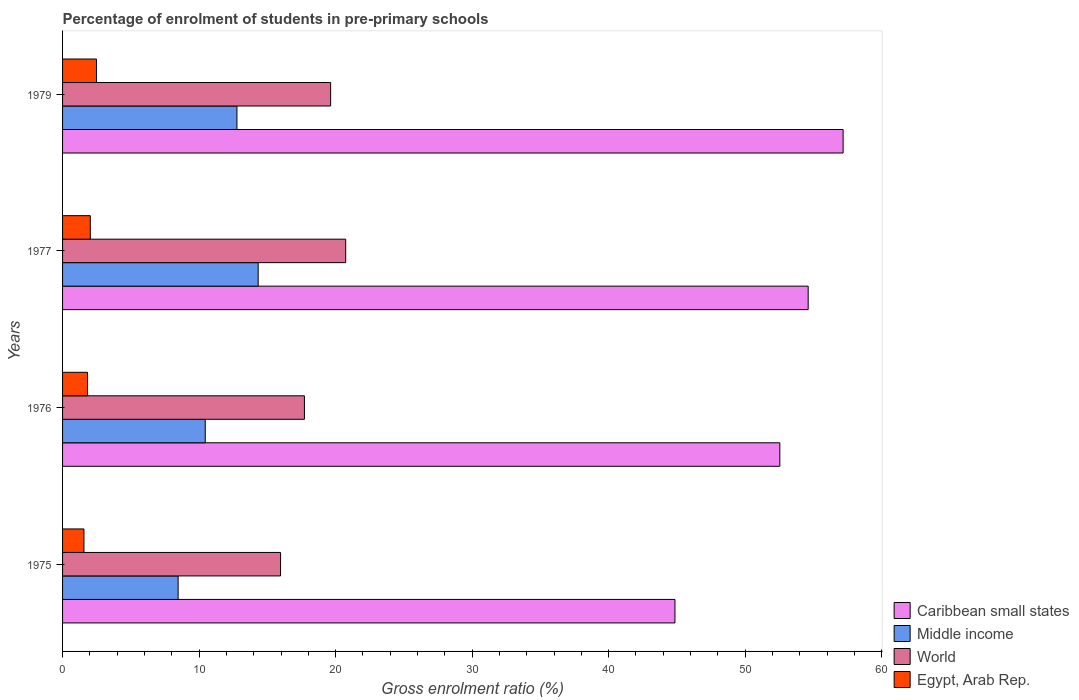How many bars are there on the 3rd tick from the bottom?
Make the answer very short. 4. What is the label of the 1st group of bars from the top?
Keep it short and to the point. 1979. What is the percentage of students enrolled in pre-primary schools in Middle income in 1975?
Make the answer very short. 8.47. Across all years, what is the maximum percentage of students enrolled in pre-primary schools in Caribbean small states?
Your answer should be compact. 57.17. Across all years, what is the minimum percentage of students enrolled in pre-primary schools in World?
Keep it short and to the point. 15.97. In which year was the percentage of students enrolled in pre-primary schools in World maximum?
Ensure brevity in your answer.  1977. In which year was the percentage of students enrolled in pre-primary schools in Egypt, Arab Rep. minimum?
Give a very brief answer. 1975. What is the total percentage of students enrolled in pre-primary schools in Caribbean small states in the graph?
Make the answer very short. 209.19. What is the difference between the percentage of students enrolled in pre-primary schools in Middle income in 1975 and that in 1976?
Your answer should be compact. -1.99. What is the difference between the percentage of students enrolled in pre-primary schools in Middle income in 1977 and the percentage of students enrolled in pre-primary schools in World in 1975?
Provide a succinct answer. -1.64. What is the average percentage of students enrolled in pre-primary schools in Middle income per year?
Offer a very short reply. 11.5. In the year 1975, what is the difference between the percentage of students enrolled in pre-primary schools in Egypt, Arab Rep. and percentage of students enrolled in pre-primary schools in Caribbean small states?
Ensure brevity in your answer.  -43.29. What is the ratio of the percentage of students enrolled in pre-primary schools in Middle income in 1975 to that in 1979?
Provide a short and direct response. 0.66. Is the percentage of students enrolled in pre-primary schools in Caribbean small states in 1976 less than that in 1977?
Provide a succinct answer. Yes. Is the difference between the percentage of students enrolled in pre-primary schools in Egypt, Arab Rep. in 1976 and 1979 greater than the difference between the percentage of students enrolled in pre-primary schools in Caribbean small states in 1976 and 1979?
Provide a short and direct response. Yes. What is the difference between the highest and the second highest percentage of students enrolled in pre-primary schools in Middle income?
Make the answer very short. 1.56. What is the difference between the highest and the lowest percentage of students enrolled in pre-primary schools in World?
Offer a very short reply. 4.77. Is the sum of the percentage of students enrolled in pre-primary schools in Egypt, Arab Rep. in 1975 and 1977 greater than the maximum percentage of students enrolled in pre-primary schools in World across all years?
Your answer should be very brief. No. What does the 1st bar from the top in 1979 represents?
Ensure brevity in your answer.  Egypt, Arab Rep. What does the 4th bar from the bottom in 1977 represents?
Ensure brevity in your answer.  Egypt, Arab Rep. How many years are there in the graph?
Keep it short and to the point. 4. Are the values on the major ticks of X-axis written in scientific E-notation?
Provide a short and direct response. No. Does the graph contain any zero values?
Keep it short and to the point. No. Does the graph contain grids?
Offer a very short reply. No. How are the legend labels stacked?
Keep it short and to the point. Vertical. What is the title of the graph?
Provide a succinct answer. Percentage of enrolment of students in pre-primary schools. What is the label or title of the Y-axis?
Your response must be concise. Years. What is the Gross enrolment ratio (%) of Caribbean small states in 1975?
Provide a short and direct response. 44.86. What is the Gross enrolment ratio (%) in Middle income in 1975?
Provide a short and direct response. 8.47. What is the Gross enrolment ratio (%) in World in 1975?
Keep it short and to the point. 15.97. What is the Gross enrolment ratio (%) in Egypt, Arab Rep. in 1975?
Offer a terse response. 1.57. What is the Gross enrolment ratio (%) of Caribbean small states in 1976?
Make the answer very short. 52.54. What is the Gross enrolment ratio (%) in Middle income in 1976?
Ensure brevity in your answer.  10.45. What is the Gross enrolment ratio (%) in World in 1976?
Offer a terse response. 17.72. What is the Gross enrolment ratio (%) in Egypt, Arab Rep. in 1976?
Offer a terse response. 1.83. What is the Gross enrolment ratio (%) in Caribbean small states in 1977?
Offer a very short reply. 54.61. What is the Gross enrolment ratio (%) in Middle income in 1977?
Provide a succinct answer. 14.33. What is the Gross enrolment ratio (%) of World in 1977?
Ensure brevity in your answer.  20.74. What is the Gross enrolment ratio (%) in Egypt, Arab Rep. in 1977?
Ensure brevity in your answer.  2.03. What is the Gross enrolment ratio (%) in Caribbean small states in 1979?
Keep it short and to the point. 57.17. What is the Gross enrolment ratio (%) of Middle income in 1979?
Your answer should be compact. 12.77. What is the Gross enrolment ratio (%) in World in 1979?
Provide a short and direct response. 19.64. What is the Gross enrolment ratio (%) of Egypt, Arab Rep. in 1979?
Your answer should be very brief. 2.48. Across all years, what is the maximum Gross enrolment ratio (%) in Caribbean small states?
Keep it short and to the point. 57.17. Across all years, what is the maximum Gross enrolment ratio (%) in Middle income?
Offer a terse response. 14.33. Across all years, what is the maximum Gross enrolment ratio (%) in World?
Your answer should be compact. 20.74. Across all years, what is the maximum Gross enrolment ratio (%) in Egypt, Arab Rep.?
Your response must be concise. 2.48. Across all years, what is the minimum Gross enrolment ratio (%) of Caribbean small states?
Make the answer very short. 44.86. Across all years, what is the minimum Gross enrolment ratio (%) in Middle income?
Your answer should be very brief. 8.47. Across all years, what is the minimum Gross enrolment ratio (%) in World?
Provide a succinct answer. 15.97. Across all years, what is the minimum Gross enrolment ratio (%) in Egypt, Arab Rep.?
Your answer should be very brief. 1.57. What is the total Gross enrolment ratio (%) of Caribbean small states in the graph?
Offer a very short reply. 209.19. What is the total Gross enrolment ratio (%) of Middle income in the graph?
Provide a short and direct response. 46.02. What is the total Gross enrolment ratio (%) in World in the graph?
Your response must be concise. 74.06. What is the total Gross enrolment ratio (%) of Egypt, Arab Rep. in the graph?
Your answer should be compact. 7.91. What is the difference between the Gross enrolment ratio (%) of Caribbean small states in 1975 and that in 1976?
Make the answer very short. -7.68. What is the difference between the Gross enrolment ratio (%) of Middle income in 1975 and that in 1976?
Make the answer very short. -1.99. What is the difference between the Gross enrolment ratio (%) in World in 1975 and that in 1976?
Your response must be concise. -1.75. What is the difference between the Gross enrolment ratio (%) of Egypt, Arab Rep. in 1975 and that in 1976?
Provide a succinct answer. -0.26. What is the difference between the Gross enrolment ratio (%) of Caribbean small states in 1975 and that in 1977?
Offer a very short reply. -9.76. What is the difference between the Gross enrolment ratio (%) of Middle income in 1975 and that in 1977?
Your answer should be very brief. -5.86. What is the difference between the Gross enrolment ratio (%) of World in 1975 and that in 1977?
Provide a short and direct response. -4.77. What is the difference between the Gross enrolment ratio (%) in Egypt, Arab Rep. in 1975 and that in 1977?
Provide a short and direct response. -0.47. What is the difference between the Gross enrolment ratio (%) of Caribbean small states in 1975 and that in 1979?
Give a very brief answer. -12.32. What is the difference between the Gross enrolment ratio (%) in Middle income in 1975 and that in 1979?
Provide a short and direct response. -4.31. What is the difference between the Gross enrolment ratio (%) of World in 1975 and that in 1979?
Your answer should be compact. -3.67. What is the difference between the Gross enrolment ratio (%) of Egypt, Arab Rep. in 1975 and that in 1979?
Your response must be concise. -0.92. What is the difference between the Gross enrolment ratio (%) in Caribbean small states in 1976 and that in 1977?
Offer a very short reply. -2.07. What is the difference between the Gross enrolment ratio (%) in Middle income in 1976 and that in 1977?
Make the answer very short. -3.88. What is the difference between the Gross enrolment ratio (%) in World in 1976 and that in 1977?
Your answer should be very brief. -3.02. What is the difference between the Gross enrolment ratio (%) in Egypt, Arab Rep. in 1976 and that in 1977?
Offer a terse response. -0.2. What is the difference between the Gross enrolment ratio (%) in Caribbean small states in 1976 and that in 1979?
Your answer should be very brief. -4.63. What is the difference between the Gross enrolment ratio (%) in Middle income in 1976 and that in 1979?
Offer a very short reply. -2.32. What is the difference between the Gross enrolment ratio (%) in World in 1976 and that in 1979?
Your answer should be compact. -1.92. What is the difference between the Gross enrolment ratio (%) of Egypt, Arab Rep. in 1976 and that in 1979?
Make the answer very short. -0.66. What is the difference between the Gross enrolment ratio (%) in Caribbean small states in 1977 and that in 1979?
Make the answer very short. -2.56. What is the difference between the Gross enrolment ratio (%) in Middle income in 1977 and that in 1979?
Keep it short and to the point. 1.56. What is the difference between the Gross enrolment ratio (%) in World in 1977 and that in 1979?
Provide a short and direct response. 1.1. What is the difference between the Gross enrolment ratio (%) in Egypt, Arab Rep. in 1977 and that in 1979?
Keep it short and to the point. -0.45. What is the difference between the Gross enrolment ratio (%) in Caribbean small states in 1975 and the Gross enrolment ratio (%) in Middle income in 1976?
Your answer should be compact. 34.41. What is the difference between the Gross enrolment ratio (%) in Caribbean small states in 1975 and the Gross enrolment ratio (%) in World in 1976?
Your answer should be very brief. 27.14. What is the difference between the Gross enrolment ratio (%) in Caribbean small states in 1975 and the Gross enrolment ratio (%) in Egypt, Arab Rep. in 1976?
Make the answer very short. 43.03. What is the difference between the Gross enrolment ratio (%) of Middle income in 1975 and the Gross enrolment ratio (%) of World in 1976?
Ensure brevity in your answer.  -9.25. What is the difference between the Gross enrolment ratio (%) in Middle income in 1975 and the Gross enrolment ratio (%) in Egypt, Arab Rep. in 1976?
Your answer should be compact. 6.64. What is the difference between the Gross enrolment ratio (%) in World in 1975 and the Gross enrolment ratio (%) in Egypt, Arab Rep. in 1976?
Provide a succinct answer. 14.14. What is the difference between the Gross enrolment ratio (%) in Caribbean small states in 1975 and the Gross enrolment ratio (%) in Middle income in 1977?
Offer a very short reply. 30.53. What is the difference between the Gross enrolment ratio (%) of Caribbean small states in 1975 and the Gross enrolment ratio (%) of World in 1977?
Provide a succinct answer. 24.12. What is the difference between the Gross enrolment ratio (%) of Caribbean small states in 1975 and the Gross enrolment ratio (%) of Egypt, Arab Rep. in 1977?
Offer a terse response. 42.82. What is the difference between the Gross enrolment ratio (%) in Middle income in 1975 and the Gross enrolment ratio (%) in World in 1977?
Keep it short and to the point. -12.27. What is the difference between the Gross enrolment ratio (%) in Middle income in 1975 and the Gross enrolment ratio (%) in Egypt, Arab Rep. in 1977?
Your answer should be compact. 6.43. What is the difference between the Gross enrolment ratio (%) in World in 1975 and the Gross enrolment ratio (%) in Egypt, Arab Rep. in 1977?
Your response must be concise. 13.94. What is the difference between the Gross enrolment ratio (%) in Caribbean small states in 1975 and the Gross enrolment ratio (%) in Middle income in 1979?
Your answer should be compact. 32.08. What is the difference between the Gross enrolment ratio (%) in Caribbean small states in 1975 and the Gross enrolment ratio (%) in World in 1979?
Your answer should be compact. 25.22. What is the difference between the Gross enrolment ratio (%) in Caribbean small states in 1975 and the Gross enrolment ratio (%) in Egypt, Arab Rep. in 1979?
Give a very brief answer. 42.37. What is the difference between the Gross enrolment ratio (%) of Middle income in 1975 and the Gross enrolment ratio (%) of World in 1979?
Keep it short and to the point. -11.17. What is the difference between the Gross enrolment ratio (%) in Middle income in 1975 and the Gross enrolment ratio (%) in Egypt, Arab Rep. in 1979?
Make the answer very short. 5.98. What is the difference between the Gross enrolment ratio (%) of World in 1975 and the Gross enrolment ratio (%) of Egypt, Arab Rep. in 1979?
Make the answer very short. 13.48. What is the difference between the Gross enrolment ratio (%) of Caribbean small states in 1976 and the Gross enrolment ratio (%) of Middle income in 1977?
Make the answer very short. 38.21. What is the difference between the Gross enrolment ratio (%) of Caribbean small states in 1976 and the Gross enrolment ratio (%) of World in 1977?
Provide a short and direct response. 31.8. What is the difference between the Gross enrolment ratio (%) in Caribbean small states in 1976 and the Gross enrolment ratio (%) in Egypt, Arab Rep. in 1977?
Your answer should be very brief. 50.51. What is the difference between the Gross enrolment ratio (%) of Middle income in 1976 and the Gross enrolment ratio (%) of World in 1977?
Provide a short and direct response. -10.29. What is the difference between the Gross enrolment ratio (%) in Middle income in 1976 and the Gross enrolment ratio (%) in Egypt, Arab Rep. in 1977?
Keep it short and to the point. 8.42. What is the difference between the Gross enrolment ratio (%) in World in 1976 and the Gross enrolment ratio (%) in Egypt, Arab Rep. in 1977?
Offer a terse response. 15.68. What is the difference between the Gross enrolment ratio (%) in Caribbean small states in 1976 and the Gross enrolment ratio (%) in Middle income in 1979?
Give a very brief answer. 39.77. What is the difference between the Gross enrolment ratio (%) in Caribbean small states in 1976 and the Gross enrolment ratio (%) in World in 1979?
Make the answer very short. 32.9. What is the difference between the Gross enrolment ratio (%) of Caribbean small states in 1976 and the Gross enrolment ratio (%) of Egypt, Arab Rep. in 1979?
Provide a short and direct response. 50.06. What is the difference between the Gross enrolment ratio (%) in Middle income in 1976 and the Gross enrolment ratio (%) in World in 1979?
Your answer should be very brief. -9.19. What is the difference between the Gross enrolment ratio (%) in Middle income in 1976 and the Gross enrolment ratio (%) in Egypt, Arab Rep. in 1979?
Keep it short and to the point. 7.97. What is the difference between the Gross enrolment ratio (%) of World in 1976 and the Gross enrolment ratio (%) of Egypt, Arab Rep. in 1979?
Give a very brief answer. 15.23. What is the difference between the Gross enrolment ratio (%) in Caribbean small states in 1977 and the Gross enrolment ratio (%) in Middle income in 1979?
Ensure brevity in your answer.  41.84. What is the difference between the Gross enrolment ratio (%) in Caribbean small states in 1977 and the Gross enrolment ratio (%) in World in 1979?
Provide a succinct answer. 34.98. What is the difference between the Gross enrolment ratio (%) in Caribbean small states in 1977 and the Gross enrolment ratio (%) in Egypt, Arab Rep. in 1979?
Provide a short and direct response. 52.13. What is the difference between the Gross enrolment ratio (%) in Middle income in 1977 and the Gross enrolment ratio (%) in World in 1979?
Your response must be concise. -5.31. What is the difference between the Gross enrolment ratio (%) in Middle income in 1977 and the Gross enrolment ratio (%) in Egypt, Arab Rep. in 1979?
Your answer should be very brief. 11.84. What is the difference between the Gross enrolment ratio (%) of World in 1977 and the Gross enrolment ratio (%) of Egypt, Arab Rep. in 1979?
Ensure brevity in your answer.  18.25. What is the average Gross enrolment ratio (%) of Caribbean small states per year?
Your response must be concise. 52.3. What is the average Gross enrolment ratio (%) of Middle income per year?
Your response must be concise. 11.5. What is the average Gross enrolment ratio (%) of World per year?
Keep it short and to the point. 18.51. What is the average Gross enrolment ratio (%) in Egypt, Arab Rep. per year?
Offer a terse response. 1.98. In the year 1975, what is the difference between the Gross enrolment ratio (%) in Caribbean small states and Gross enrolment ratio (%) in Middle income?
Your answer should be compact. 36.39. In the year 1975, what is the difference between the Gross enrolment ratio (%) of Caribbean small states and Gross enrolment ratio (%) of World?
Ensure brevity in your answer.  28.89. In the year 1975, what is the difference between the Gross enrolment ratio (%) in Caribbean small states and Gross enrolment ratio (%) in Egypt, Arab Rep.?
Offer a very short reply. 43.29. In the year 1975, what is the difference between the Gross enrolment ratio (%) in Middle income and Gross enrolment ratio (%) in World?
Your response must be concise. -7.5. In the year 1975, what is the difference between the Gross enrolment ratio (%) in Middle income and Gross enrolment ratio (%) in Egypt, Arab Rep.?
Your response must be concise. 6.9. In the year 1975, what is the difference between the Gross enrolment ratio (%) of World and Gross enrolment ratio (%) of Egypt, Arab Rep.?
Ensure brevity in your answer.  14.4. In the year 1976, what is the difference between the Gross enrolment ratio (%) in Caribbean small states and Gross enrolment ratio (%) in Middle income?
Give a very brief answer. 42.09. In the year 1976, what is the difference between the Gross enrolment ratio (%) in Caribbean small states and Gross enrolment ratio (%) in World?
Provide a short and direct response. 34.82. In the year 1976, what is the difference between the Gross enrolment ratio (%) of Caribbean small states and Gross enrolment ratio (%) of Egypt, Arab Rep.?
Provide a succinct answer. 50.71. In the year 1976, what is the difference between the Gross enrolment ratio (%) in Middle income and Gross enrolment ratio (%) in World?
Your response must be concise. -7.26. In the year 1976, what is the difference between the Gross enrolment ratio (%) of Middle income and Gross enrolment ratio (%) of Egypt, Arab Rep.?
Provide a succinct answer. 8.62. In the year 1976, what is the difference between the Gross enrolment ratio (%) in World and Gross enrolment ratio (%) in Egypt, Arab Rep.?
Offer a terse response. 15.89. In the year 1977, what is the difference between the Gross enrolment ratio (%) in Caribbean small states and Gross enrolment ratio (%) in Middle income?
Keep it short and to the point. 40.29. In the year 1977, what is the difference between the Gross enrolment ratio (%) in Caribbean small states and Gross enrolment ratio (%) in World?
Keep it short and to the point. 33.88. In the year 1977, what is the difference between the Gross enrolment ratio (%) in Caribbean small states and Gross enrolment ratio (%) in Egypt, Arab Rep.?
Provide a short and direct response. 52.58. In the year 1977, what is the difference between the Gross enrolment ratio (%) in Middle income and Gross enrolment ratio (%) in World?
Your answer should be compact. -6.41. In the year 1977, what is the difference between the Gross enrolment ratio (%) in Middle income and Gross enrolment ratio (%) in Egypt, Arab Rep.?
Ensure brevity in your answer.  12.3. In the year 1977, what is the difference between the Gross enrolment ratio (%) of World and Gross enrolment ratio (%) of Egypt, Arab Rep.?
Provide a short and direct response. 18.71. In the year 1979, what is the difference between the Gross enrolment ratio (%) in Caribbean small states and Gross enrolment ratio (%) in Middle income?
Give a very brief answer. 44.4. In the year 1979, what is the difference between the Gross enrolment ratio (%) in Caribbean small states and Gross enrolment ratio (%) in World?
Give a very brief answer. 37.54. In the year 1979, what is the difference between the Gross enrolment ratio (%) in Caribbean small states and Gross enrolment ratio (%) in Egypt, Arab Rep.?
Your response must be concise. 54.69. In the year 1979, what is the difference between the Gross enrolment ratio (%) in Middle income and Gross enrolment ratio (%) in World?
Provide a succinct answer. -6.86. In the year 1979, what is the difference between the Gross enrolment ratio (%) in Middle income and Gross enrolment ratio (%) in Egypt, Arab Rep.?
Your response must be concise. 10.29. In the year 1979, what is the difference between the Gross enrolment ratio (%) of World and Gross enrolment ratio (%) of Egypt, Arab Rep.?
Give a very brief answer. 17.15. What is the ratio of the Gross enrolment ratio (%) of Caribbean small states in 1975 to that in 1976?
Your answer should be very brief. 0.85. What is the ratio of the Gross enrolment ratio (%) of Middle income in 1975 to that in 1976?
Offer a very short reply. 0.81. What is the ratio of the Gross enrolment ratio (%) in World in 1975 to that in 1976?
Keep it short and to the point. 0.9. What is the ratio of the Gross enrolment ratio (%) of Egypt, Arab Rep. in 1975 to that in 1976?
Your response must be concise. 0.86. What is the ratio of the Gross enrolment ratio (%) of Caribbean small states in 1975 to that in 1977?
Make the answer very short. 0.82. What is the ratio of the Gross enrolment ratio (%) of Middle income in 1975 to that in 1977?
Make the answer very short. 0.59. What is the ratio of the Gross enrolment ratio (%) of World in 1975 to that in 1977?
Your answer should be very brief. 0.77. What is the ratio of the Gross enrolment ratio (%) in Egypt, Arab Rep. in 1975 to that in 1977?
Give a very brief answer. 0.77. What is the ratio of the Gross enrolment ratio (%) in Caribbean small states in 1975 to that in 1979?
Provide a succinct answer. 0.78. What is the ratio of the Gross enrolment ratio (%) in Middle income in 1975 to that in 1979?
Your response must be concise. 0.66. What is the ratio of the Gross enrolment ratio (%) in World in 1975 to that in 1979?
Make the answer very short. 0.81. What is the ratio of the Gross enrolment ratio (%) in Egypt, Arab Rep. in 1975 to that in 1979?
Make the answer very short. 0.63. What is the ratio of the Gross enrolment ratio (%) in Caribbean small states in 1976 to that in 1977?
Your answer should be very brief. 0.96. What is the ratio of the Gross enrolment ratio (%) of Middle income in 1976 to that in 1977?
Offer a terse response. 0.73. What is the ratio of the Gross enrolment ratio (%) of World in 1976 to that in 1977?
Provide a succinct answer. 0.85. What is the ratio of the Gross enrolment ratio (%) of Egypt, Arab Rep. in 1976 to that in 1977?
Keep it short and to the point. 0.9. What is the ratio of the Gross enrolment ratio (%) in Caribbean small states in 1976 to that in 1979?
Make the answer very short. 0.92. What is the ratio of the Gross enrolment ratio (%) of Middle income in 1976 to that in 1979?
Your answer should be compact. 0.82. What is the ratio of the Gross enrolment ratio (%) of World in 1976 to that in 1979?
Give a very brief answer. 0.9. What is the ratio of the Gross enrolment ratio (%) in Egypt, Arab Rep. in 1976 to that in 1979?
Give a very brief answer. 0.74. What is the ratio of the Gross enrolment ratio (%) of Caribbean small states in 1977 to that in 1979?
Keep it short and to the point. 0.96. What is the ratio of the Gross enrolment ratio (%) of Middle income in 1977 to that in 1979?
Offer a terse response. 1.12. What is the ratio of the Gross enrolment ratio (%) in World in 1977 to that in 1979?
Your answer should be very brief. 1.06. What is the ratio of the Gross enrolment ratio (%) of Egypt, Arab Rep. in 1977 to that in 1979?
Give a very brief answer. 0.82. What is the difference between the highest and the second highest Gross enrolment ratio (%) in Caribbean small states?
Your answer should be very brief. 2.56. What is the difference between the highest and the second highest Gross enrolment ratio (%) of Middle income?
Your response must be concise. 1.56. What is the difference between the highest and the second highest Gross enrolment ratio (%) of World?
Your answer should be compact. 1.1. What is the difference between the highest and the second highest Gross enrolment ratio (%) of Egypt, Arab Rep.?
Offer a terse response. 0.45. What is the difference between the highest and the lowest Gross enrolment ratio (%) of Caribbean small states?
Keep it short and to the point. 12.32. What is the difference between the highest and the lowest Gross enrolment ratio (%) of Middle income?
Offer a terse response. 5.86. What is the difference between the highest and the lowest Gross enrolment ratio (%) of World?
Your answer should be compact. 4.77. What is the difference between the highest and the lowest Gross enrolment ratio (%) in Egypt, Arab Rep.?
Ensure brevity in your answer.  0.92. 